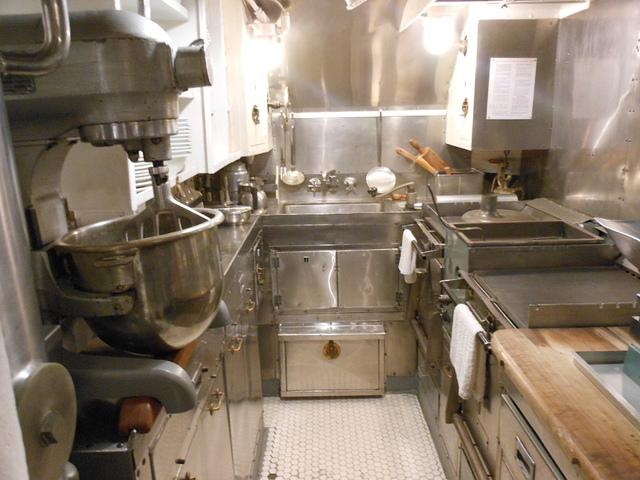How is dough kneaded here?

Choices:
A) in sink
B) by machine
C) with knives
D) hand only by machine 